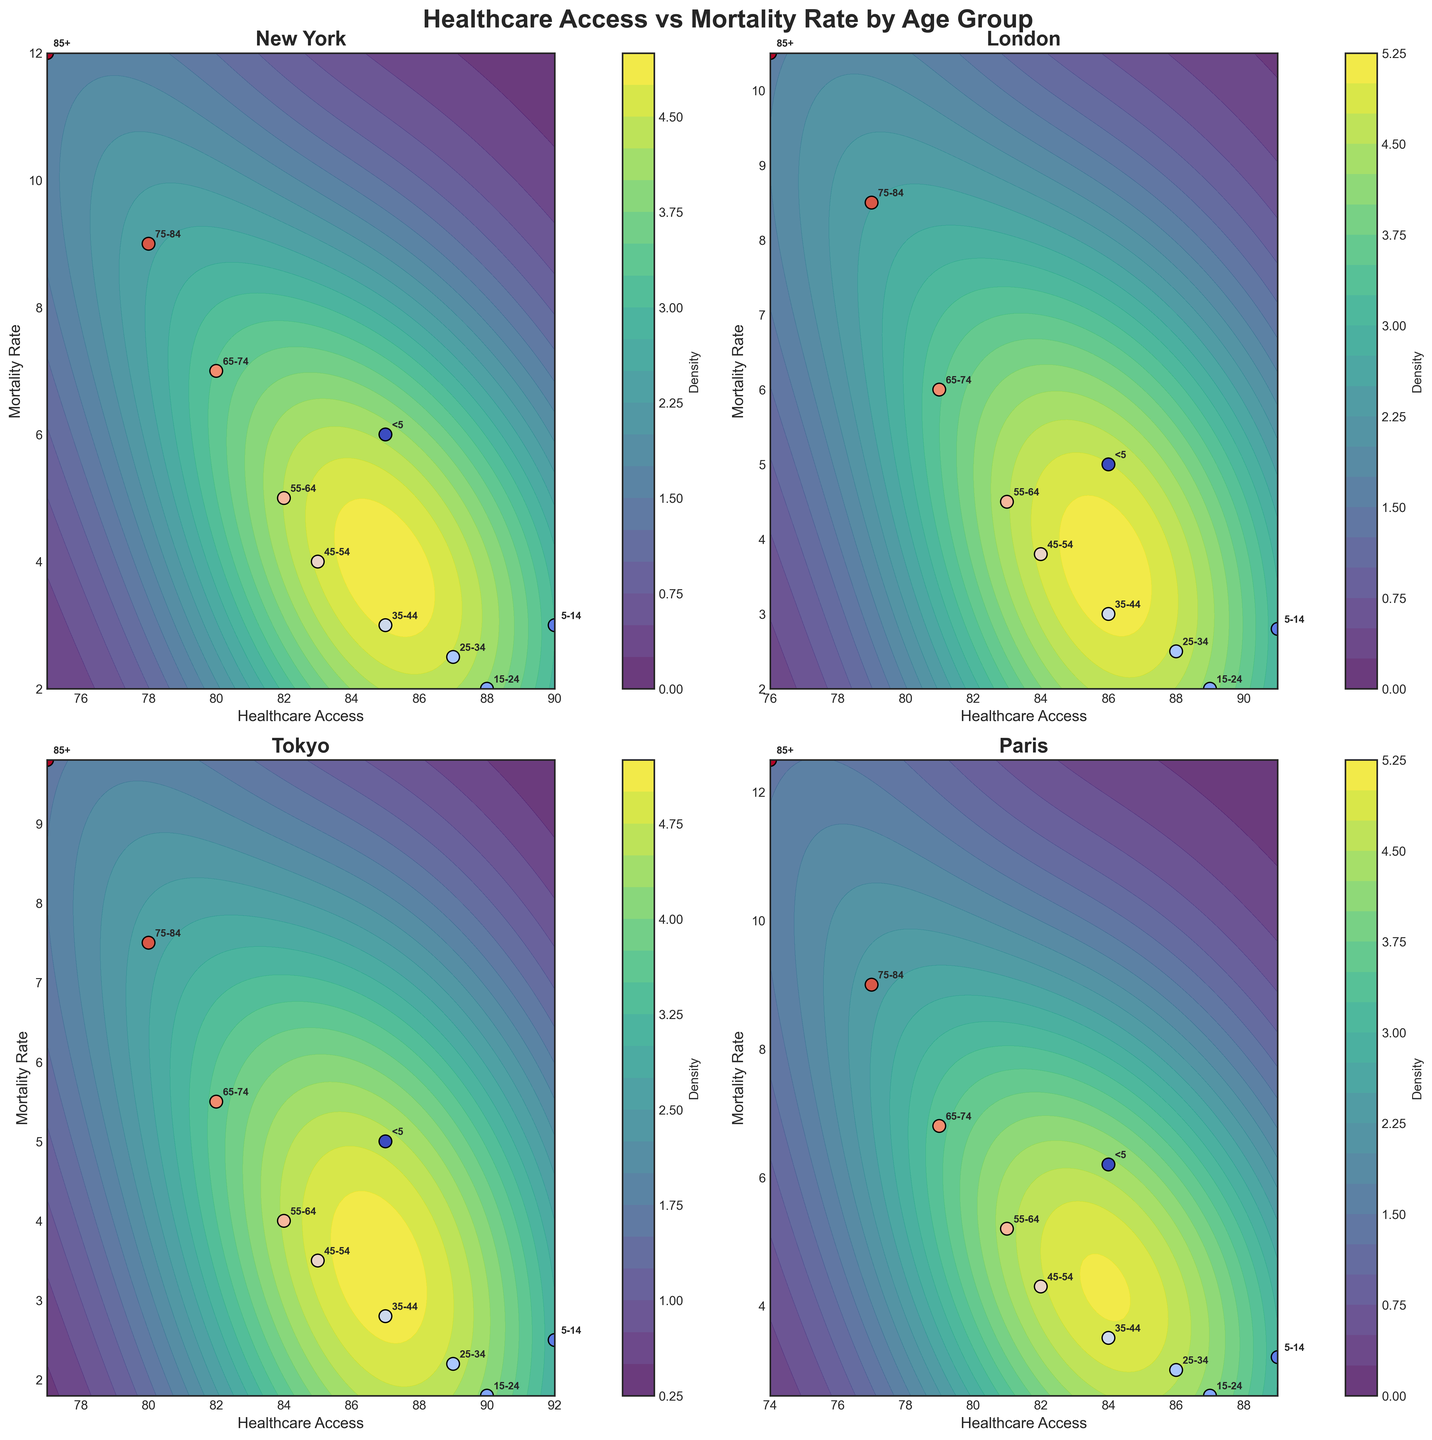What cities are represented in the figure? The figure consists of subplots for four different global cities. Each subplot is titled with the city's name.
Answer: New York, London, Tokyo, Paris What is the relationship between healthcare access and mortality rate for children under 5 in Paris? In the subplot for Paris, the point labeled '<5' has healthcare access of 84 and a mortality rate of 6.2.
Answer: Higher healthcare access correlates with a lower mortality rate Which city has the highest healthcare access for the age group '15-24'? By reviewing each subplot and locating the age group '15-24', Tokyo shows the highest healthcare access at 90.
Answer: Tokyo Compare the mortality rates for the age group '65-74' between New York and London. In New York, the '65-74' age group has a mortality rate of 7 while in London it is 6.
Answer: London has a lower rate Which age group in New York has the lowest mortality rate, and what is the healthcare access for this group? In the New York subplot, the '15-24' age group has the lowest mortality rate of 2. This age group also has a healthcare access of 88.
Answer: 15-24, 88 How does the mortality rate for people aged 85+ differ between Tokyo and Paris? For Tokyo, the mortality rate of the '85+' group is 9.8, while in Paris it is 12.5.
Answer: Paris is higher by 2.7 Which age group in Tokyo experiences the highest mortality rate? Looking at the Tokyo subplot, the '85+' age group has the highest mortality rate labeled as 9.8.
Answer: 85+ Is there any age group in London with lower healthcare access than the same group in New York? For each age group label in London, compare healthcare access with New York: No age group in London has lower healthcare access than New York.
Answer: No How does the overall trend of healthcare access and mortality rate compare between New York and Paris? Reviewing the contour lines and scatter points for New York and Paris shows a similar trend of decreasing healthcare access corresponding to an increase in mortality rate across age groups.
Answer: Similar trend Which subplot shows the least variability in healthcare access across different age groups, and how do you determine that? Observing the range of healthcare access in each subplot, Tokyo and Paris are tied with the smallest range from high 80s to mid-70s. Countour and scatter line distribution appear tightest in these plots.
Answer: Tokyo and Paris 